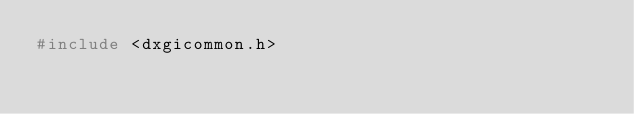Convert code to text. <code><loc_0><loc_0><loc_500><loc_500><_C_>#include <dxgicommon.h>
</code> 